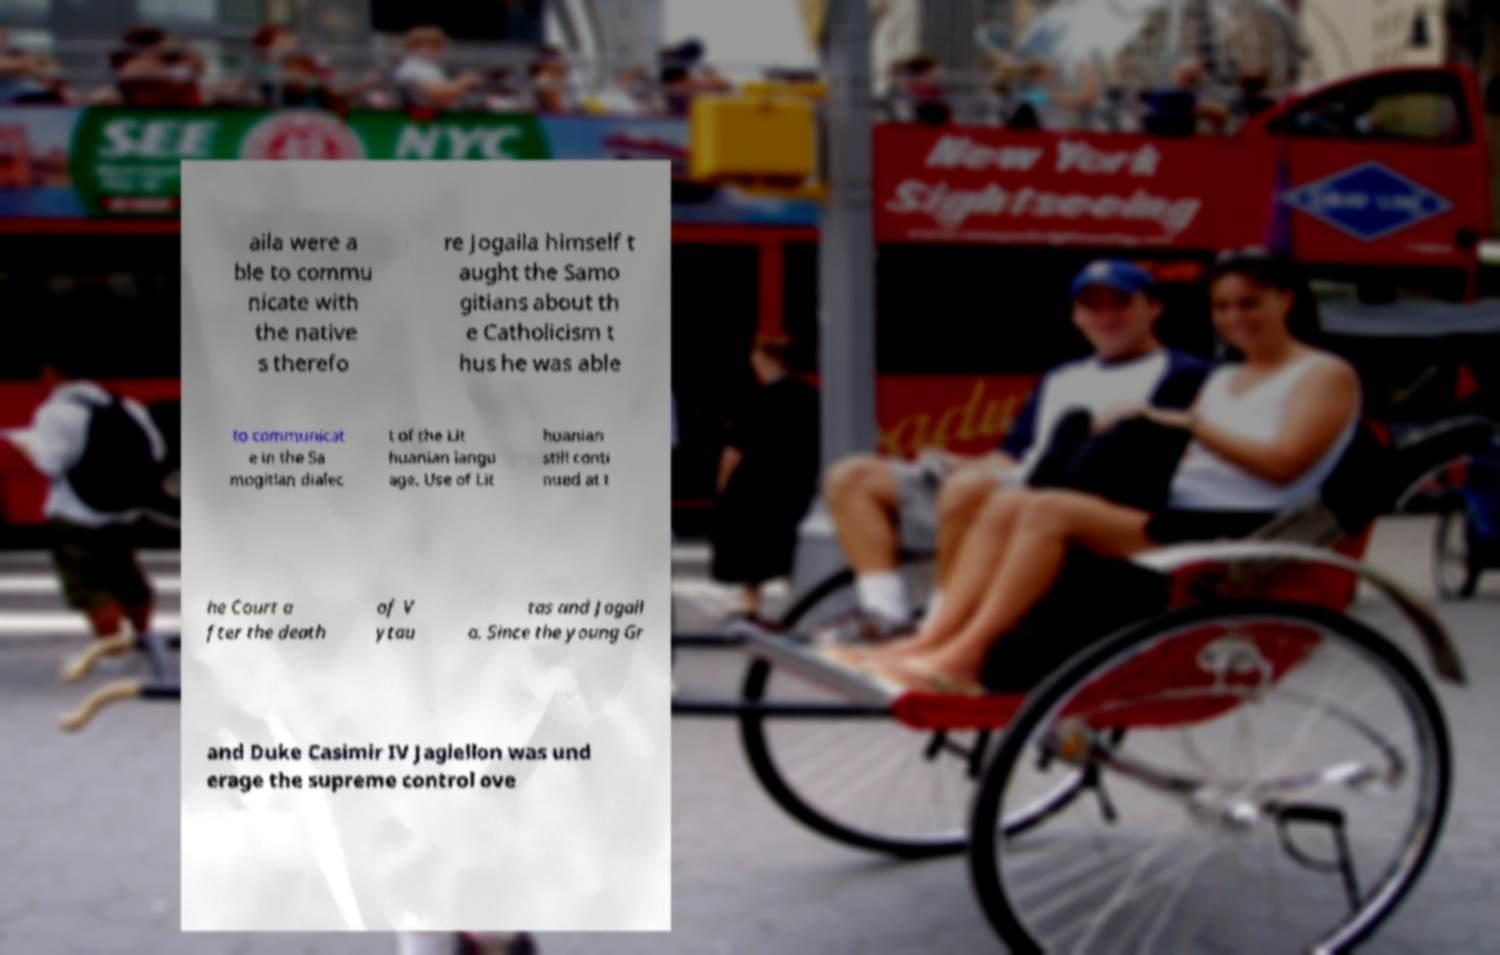Please identify and transcribe the text found in this image. aila were a ble to commu nicate with the native s therefo re Jogaila himself t aught the Samo gitians about th e Catholicism t hus he was able to communicat e in the Sa mogitian dialec t of the Lit huanian langu age. Use of Lit huanian still conti nued at t he Court a fter the death of V ytau tas and Jogail a. Since the young Gr and Duke Casimir IV Jagiellon was und erage the supreme control ove 